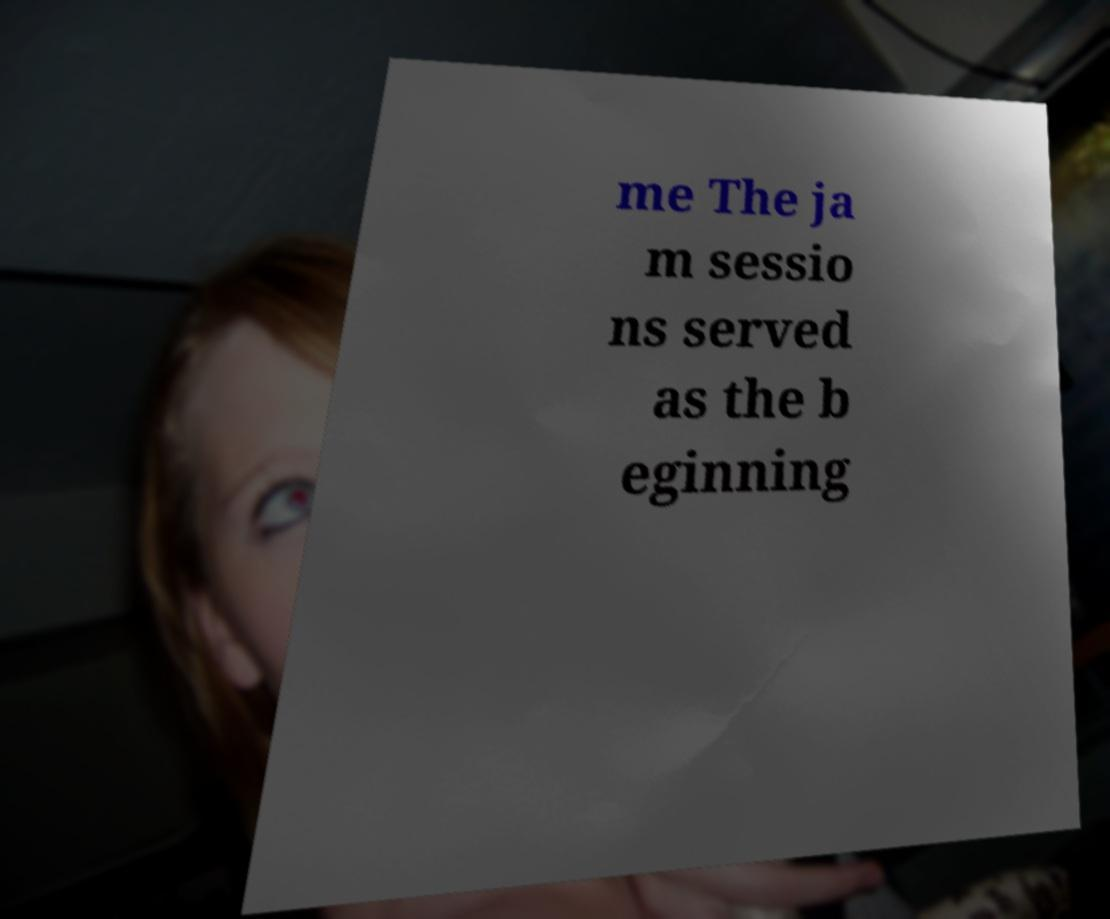For documentation purposes, I need the text within this image transcribed. Could you provide that? me The ja m sessio ns served as the b eginning 